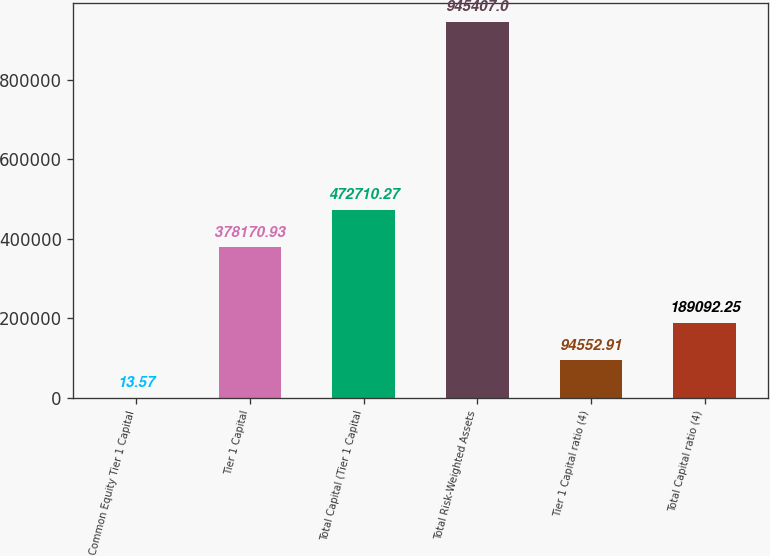<chart> <loc_0><loc_0><loc_500><loc_500><bar_chart><fcel>Common Equity Tier 1 Capital<fcel>Tier 1 Capital<fcel>Total Capital (Tier 1 Capital<fcel>Total Risk-Weighted Assets<fcel>Tier 1 Capital ratio (4)<fcel>Total Capital ratio (4)<nl><fcel>13.57<fcel>378171<fcel>472710<fcel>945407<fcel>94552.9<fcel>189092<nl></chart> 